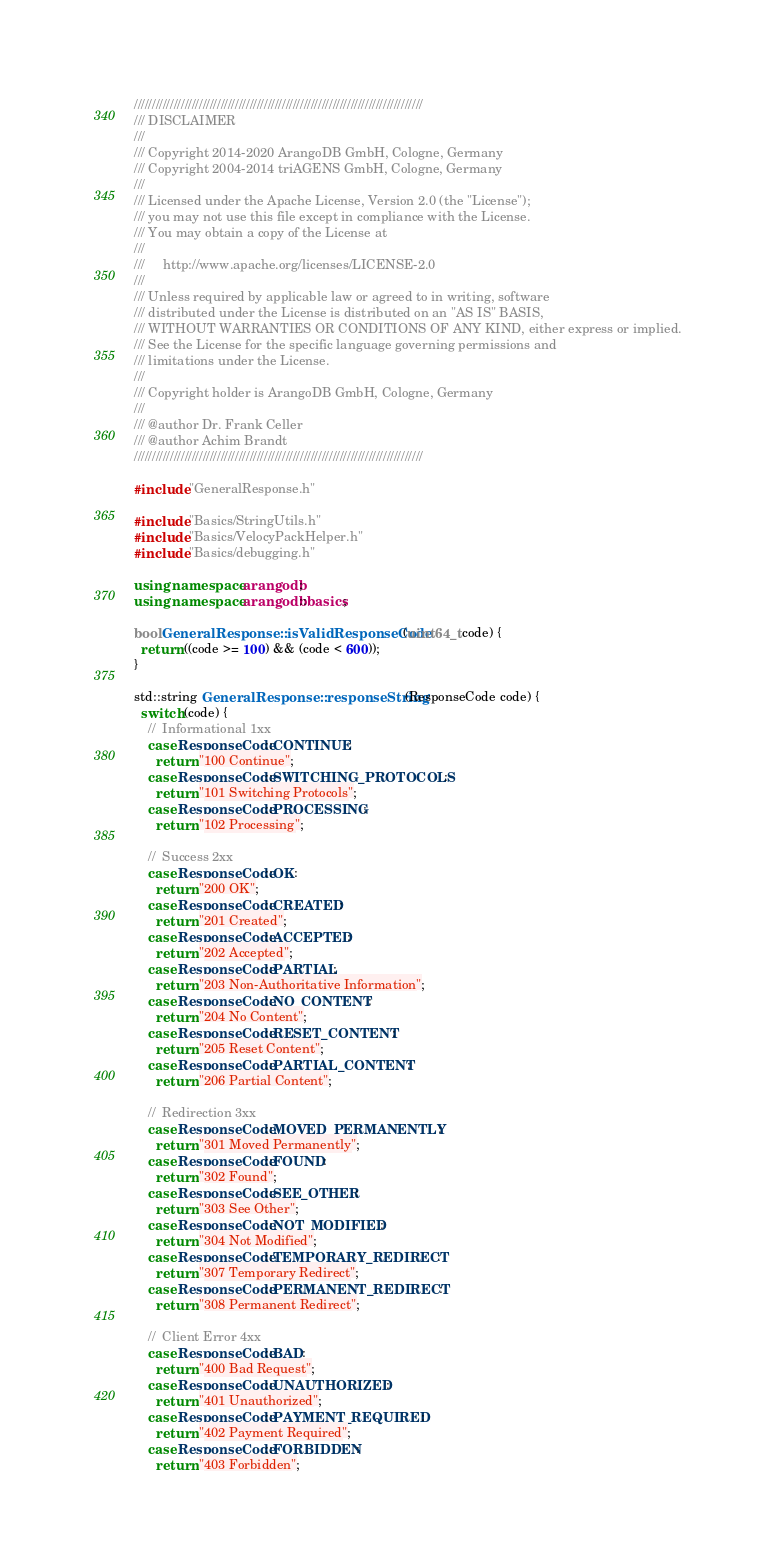<code> <loc_0><loc_0><loc_500><loc_500><_C++_>////////////////////////////////////////////////////////////////////////////////
/// DISCLAIMER
///
/// Copyright 2014-2020 ArangoDB GmbH, Cologne, Germany
/// Copyright 2004-2014 triAGENS GmbH, Cologne, Germany
///
/// Licensed under the Apache License, Version 2.0 (the "License");
/// you may not use this file except in compliance with the License.
/// You may obtain a copy of the License at
///
///     http://www.apache.org/licenses/LICENSE-2.0
///
/// Unless required by applicable law or agreed to in writing, software
/// distributed under the License is distributed on an "AS IS" BASIS,
/// WITHOUT WARRANTIES OR CONDITIONS OF ANY KIND, either express or implied.
/// See the License for the specific language governing permissions and
/// limitations under the License.
///
/// Copyright holder is ArangoDB GmbH, Cologne, Germany
///
/// @author Dr. Frank Celler
/// @author Achim Brandt
////////////////////////////////////////////////////////////////////////////////

#include "GeneralResponse.h"

#include "Basics/StringUtils.h"
#include "Basics/VelocyPackHelper.h"
#include "Basics/debugging.h"

using namespace arangodb;
using namespace arangodb::basics;

bool GeneralResponse::isValidResponseCode(uint64_t code) {
  return ((code >= 100) && (code < 600));
}

std::string GeneralResponse::responseString(ResponseCode code) {
  switch (code) {
    //  Informational 1xx
    case ResponseCode::CONTINUE:
      return "100 Continue";
    case ResponseCode::SWITCHING_PROTOCOLS:
      return "101 Switching Protocols";
    case ResponseCode::PROCESSING:
      return "102 Processing";

    //  Success 2xx
    case ResponseCode::OK:
      return "200 OK";
    case ResponseCode::CREATED:
      return "201 Created";
    case ResponseCode::ACCEPTED:
      return "202 Accepted";
    case ResponseCode::PARTIAL:
      return "203 Non-Authoritative Information";
    case ResponseCode::NO_CONTENT:
      return "204 No Content";
    case ResponseCode::RESET_CONTENT:
      return "205 Reset Content";
    case ResponseCode::PARTIAL_CONTENT:
      return "206 Partial Content";

    //  Redirection 3xx
    case ResponseCode::MOVED_PERMANENTLY:
      return "301 Moved Permanently";
    case ResponseCode::FOUND:
      return "302 Found";
    case ResponseCode::SEE_OTHER:
      return "303 See Other";
    case ResponseCode::NOT_MODIFIED:
      return "304 Not Modified";
    case ResponseCode::TEMPORARY_REDIRECT:
      return "307 Temporary Redirect";
    case ResponseCode::PERMANENT_REDIRECT:
      return "308 Permanent Redirect";

    //  Client Error 4xx
    case ResponseCode::BAD:
      return "400 Bad Request";
    case ResponseCode::UNAUTHORIZED:
      return "401 Unauthorized";
    case ResponseCode::PAYMENT_REQUIRED:
      return "402 Payment Required";
    case ResponseCode::FORBIDDEN:
      return "403 Forbidden";</code> 